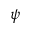Convert formula to latex. <formula><loc_0><loc_0><loc_500><loc_500>\psi</formula> 